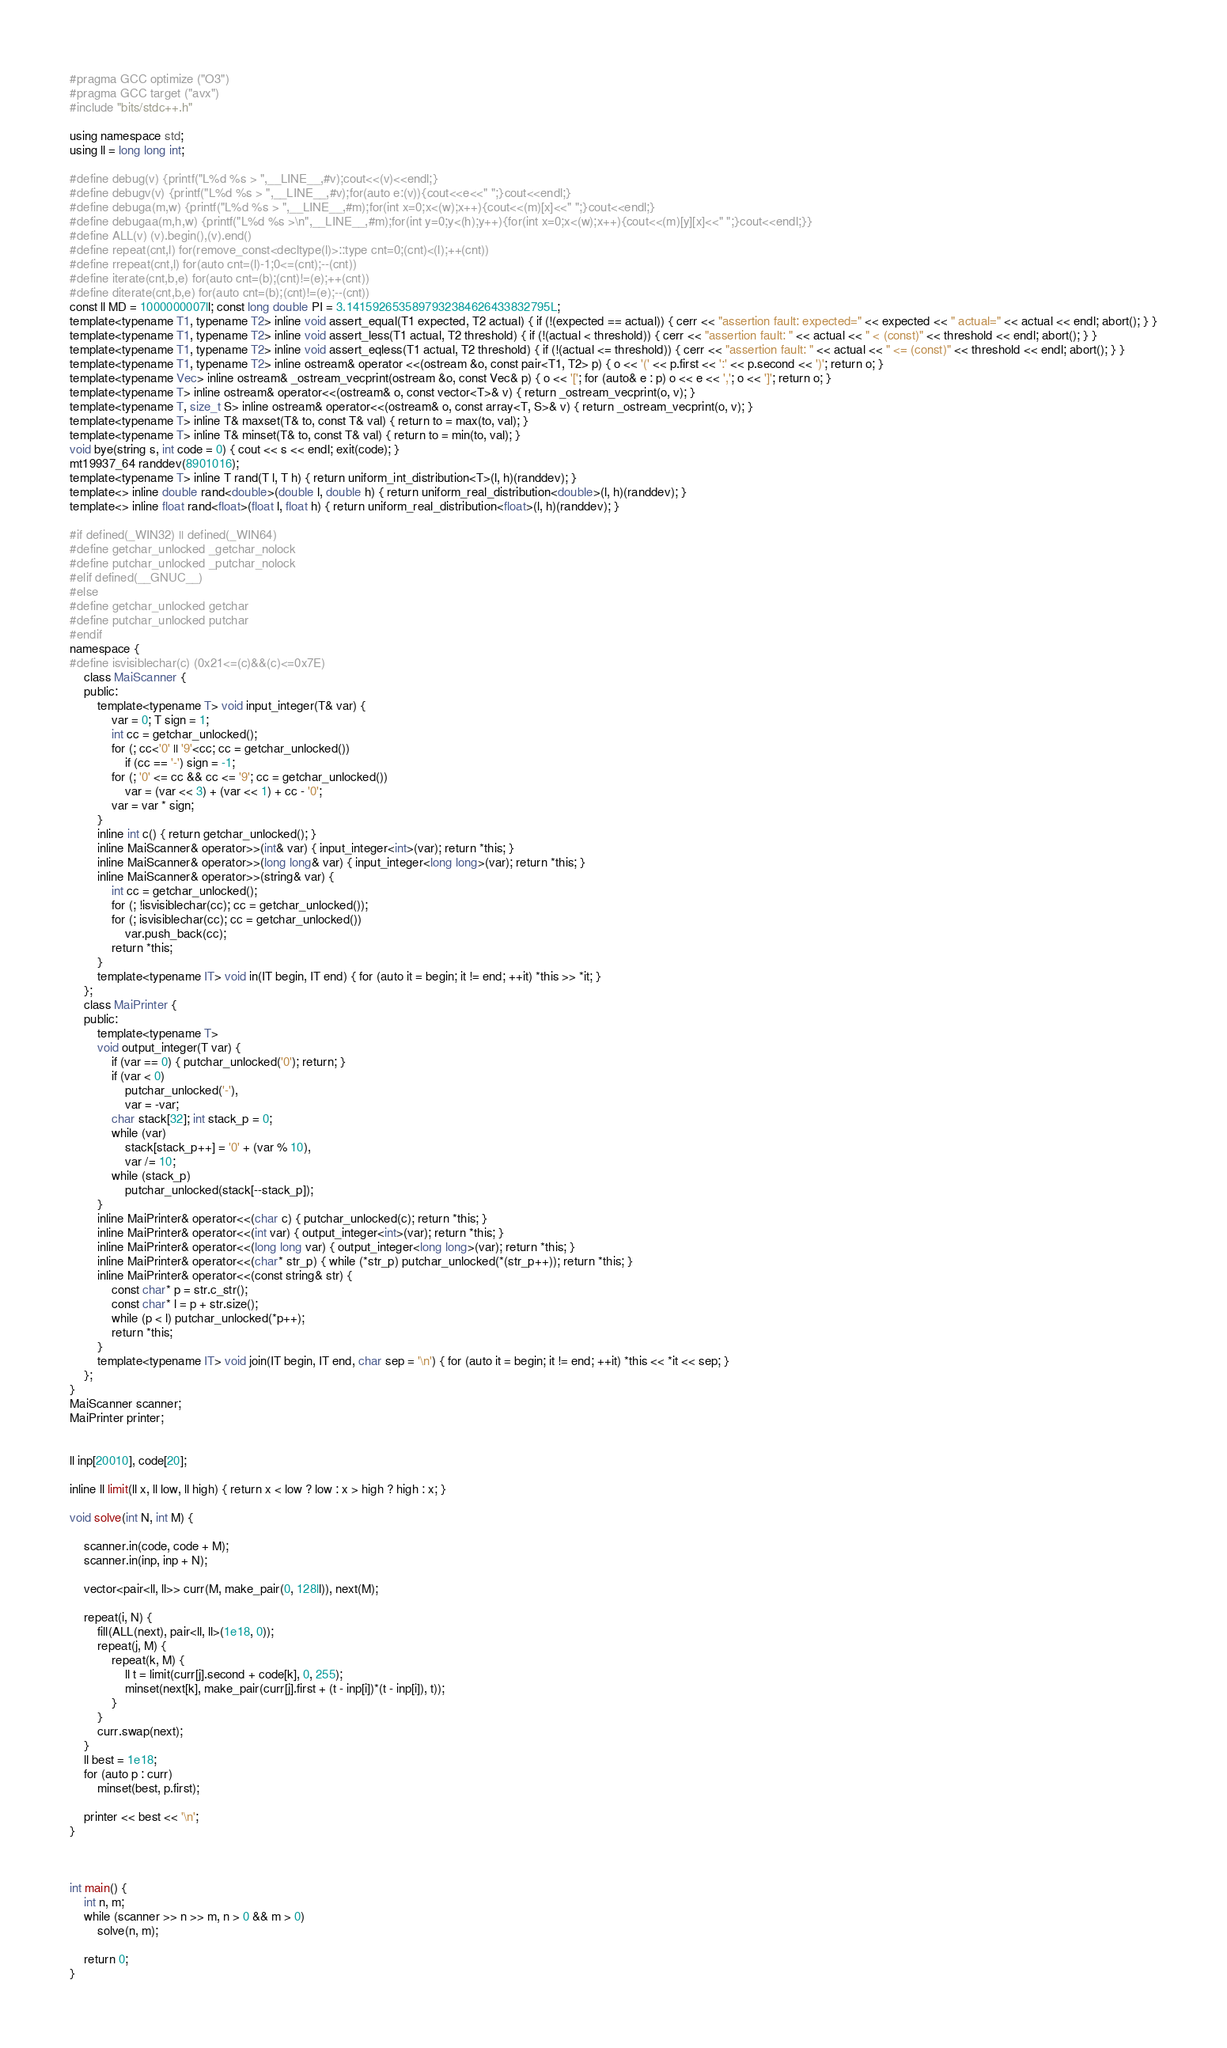<code> <loc_0><loc_0><loc_500><loc_500><_C++_>#pragma GCC optimize ("O3")
#pragma GCC target ("avx")
#include "bits/stdc++.h"

using namespace std;
using ll = long long int;

#define debug(v) {printf("L%d %s > ",__LINE__,#v);cout<<(v)<<endl;}
#define debugv(v) {printf("L%d %s > ",__LINE__,#v);for(auto e:(v)){cout<<e<<" ";}cout<<endl;}
#define debuga(m,w) {printf("L%d %s > ",__LINE__,#m);for(int x=0;x<(w);x++){cout<<(m)[x]<<" ";}cout<<endl;}
#define debugaa(m,h,w) {printf("L%d %s >\n",__LINE__,#m);for(int y=0;y<(h);y++){for(int x=0;x<(w);x++){cout<<(m)[y][x]<<" ";}cout<<endl;}}
#define ALL(v) (v).begin(),(v).end()
#define repeat(cnt,l) for(remove_const<decltype(l)>::type cnt=0;(cnt)<(l);++(cnt))
#define rrepeat(cnt,l) for(auto cnt=(l)-1;0<=(cnt);--(cnt))
#define iterate(cnt,b,e) for(auto cnt=(b);(cnt)!=(e);++(cnt))
#define diterate(cnt,b,e) for(auto cnt=(b);(cnt)!=(e);--(cnt))
const ll MD = 1000000007ll; const long double PI = 3.1415926535897932384626433832795L;
template<typename T1, typename T2> inline void assert_equal(T1 expected, T2 actual) { if (!(expected == actual)) { cerr << "assertion fault: expected=" << expected << " actual=" << actual << endl; abort(); } }
template<typename T1, typename T2> inline void assert_less(T1 actual, T2 threshold) { if (!(actual < threshold)) { cerr << "assertion fault: " << actual << " < (const)" << threshold << endl; abort(); } }
template<typename T1, typename T2> inline void assert_eqless(T1 actual, T2 threshold) { if (!(actual <= threshold)) { cerr << "assertion fault: " << actual << " <= (const)" << threshold << endl; abort(); } }
template<typename T1, typename T2> inline ostream& operator <<(ostream &o, const pair<T1, T2> p) { o << '(' << p.first << ':' << p.second << ')'; return o; }
template<typename Vec> inline ostream& _ostream_vecprint(ostream &o, const Vec& p) { o << '['; for (auto& e : p) o << e << ','; o << ']'; return o; }
template<typename T> inline ostream& operator<<(ostream& o, const vector<T>& v) { return _ostream_vecprint(o, v); }
template<typename T, size_t S> inline ostream& operator<<(ostream& o, const array<T, S>& v) { return _ostream_vecprint(o, v); }
template<typename T> inline T& maxset(T& to, const T& val) { return to = max(to, val); }
template<typename T> inline T& minset(T& to, const T& val) { return to = min(to, val); }
void bye(string s, int code = 0) { cout << s << endl; exit(code); }
mt19937_64 randdev(8901016);
template<typename T> inline T rand(T l, T h) { return uniform_int_distribution<T>(l, h)(randdev); }
template<> inline double rand<double>(double l, double h) { return uniform_real_distribution<double>(l, h)(randdev); }
template<> inline float rand<float>(float l, float h) { return uniform_real_distribution<float>(l, h)(randdev); }

#if defined(_WIN32) || defined(_WIN64)
#define getchar_unlocked _getchar_nolock
#define putchar_unlocked _putchar_nolock
#elif defined(__GNUC__)
#else
#define getchar_unlocked getchar
#define putchar_unlocked putchar
#endif
namespace {
#define isvisiblechar(c) (0x21<=(c)&&(c)<=0x7E)
    class MaiScanner {
    public:
        template<typename T> void input_integer(T& var) {
            var = 0; T sign = 1;
            int cc = getchar_unlocked();
            for (; cc<'0' || '9'<cc; cc = getchar_unlocked())
                if (cc == '-') sign = -1;
            for (; '0' <= cc && cc <= '9'; cc = getchar_unlocked())
                var = (var << 3) + (var << 1) + cc - '0';
            var = var * sign;
        }
        inline int c() { return getchar_unlocked(); }
        inline MaiScanner& operator>>(int& var) { input_integer<int>(var); return *this; }
        inline MaiScanner& operator>>(long long& var) { input_integer<long long>(var); return *this; }
        inline MaiScanner& operator>>(string& var) {
            int cc = getchar_unlocked();
            for (; !isvisiblechar(cc); cc = getchar_unlocked());
            for (; isvisiblechar(cc); cc = getchar_unlocked())
                var.push_back(cc);
            return *this;
        }
        template<typename IT> void in(IT begin, IT end) { for (auto it = begin; it != end; ++it) *this >> *it; }
    };
    class MaiPrinter {
    public:
        template<typename T>
        void output_integer(T var) {
            if (var == 0) { putchar_unlocked('0'); return; }
            if (var < 0)
                putchar_unlocked('-'),
                var = -var;
            char stack[32]; int stack_p = 0;
            while (var)
                stack[stack_p++] = '0' + (var % 10),
                var /= 10;
            while (stack_p)
                putchar_unlocked(stack[--stack_p]);
        }
        inline MaiPrinter& operator<<(char c) { putchar_unlocked(c); return *this; }
        inline MaiPrinter& operator<<(int var) { output_integer<int>(var); return *this; }
        inline MaiPrinter& operator<<(long long var) { output_integer<long long>(var); return *this; }
        inline MaiPrinter& operator<<(char* str_p) { while (*str_p) putchar_unlocked(*(str_p++)); return *this; }
        inline MaiPrinter& operator<<(const string& str) {
            const char* p = str.c_str();
            const char* l = p + str.size();
            while (p < l) putchar_unlocked(*p++);
            return *this;
        }
        template<typename IT> void join(IT begin, IT end, char sep = '\n') { for (auto it = begin; it != end; ++it) *this << *it << sep; }
    };
}
MaiScanner scanner;
MaiPrinter printer;


ll inp[20010], code[20];

inline ll limit(ll x, ll low, ll high) { return x < low ? low : x > high ? high : x; }

void solve(int N, int M) {

    scanner.in(code, code + M);
    scanner.in(inp, inp + N);

    vector<pair<ll, ll>> curr(M, make_pair(0, 128ll)), next(M);

    repeat(i, N) {
        fill(ALL(next), pair<ll, ll>(1e18, 0));
        repeat(j, M) {
            repeat(k, M) {
                ll t = limit(curr[j].second + code[k], 0, 255);
                minset(next[k], make_pair(curr[j].first + (t - inp[i])*(t - inp[i]), t));
            }
        }
        curr.swap(next);
    }
    ll best = 1e18;
    for (auto p : curr)
        minset(best, p.first);

    printer << best << '\n';
}



int main() {
    int n, m;
    while (scanner >> n >> m, n > 0 && m > 0)
        solve(n, m);

    return 0;
}
</code> 